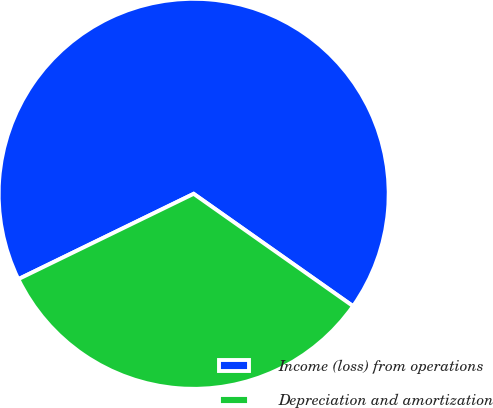Convert chart to OTSL. <chart><loc_0><loc_0><loc_500><loc_500><pie_chart><fcel>Income (loss) from operations<fcel>Depreciation and amortization<nl><fcel>66.98%<fcel>33.02%<nl></chart> 